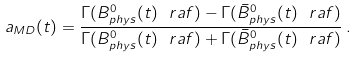Convert formula to latex. <formula><loc_0><loc_0><loc_500><loc_500>a _ { M D } ( t ) = \frac { \Gamma ( B ^ { 0 } _ { p h y s } ( t ) \ r a f ) - \Gamma ( \bar { B } ^ { 0 } _ { p h y s } ( t ) \ r a f ) } { \Gamma ( B ^ { 0 } _ { p h y s } ( t ) \ r a f ) + \Gamma ( \bar { B } ^ { 0 } _ { p h y s } ( t ) \ r a f ) } \, .</formula> 